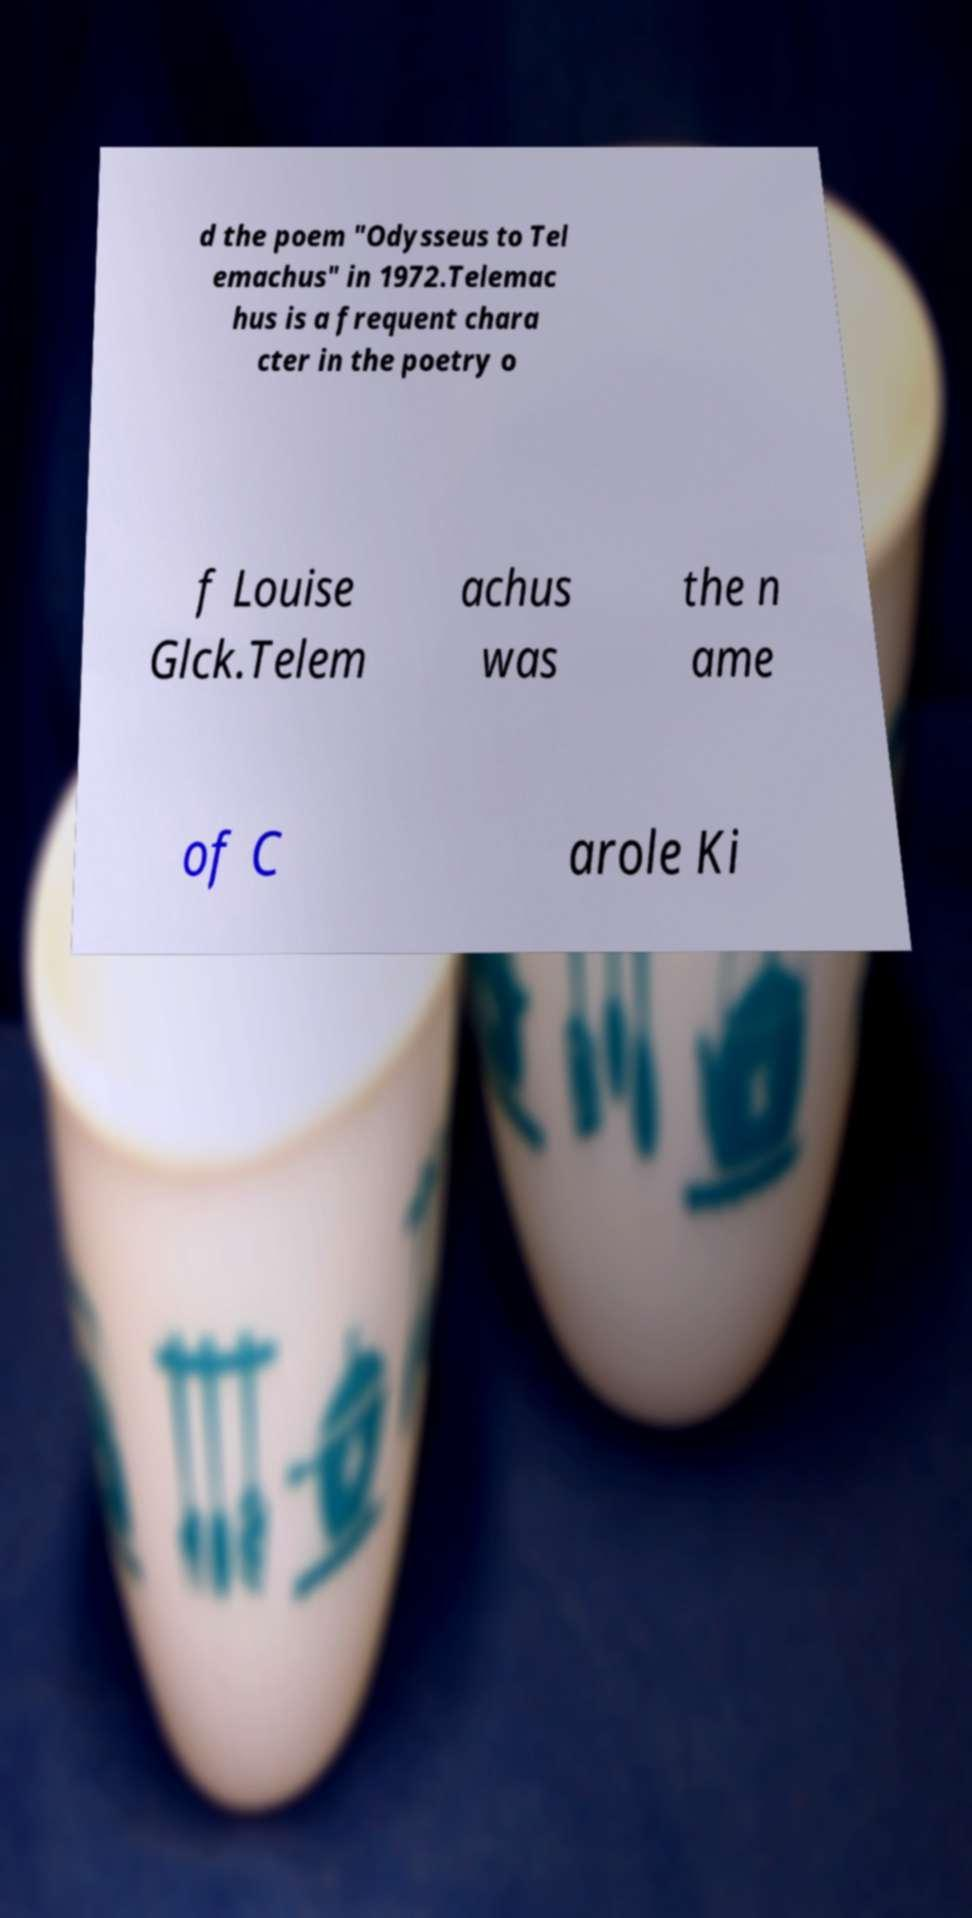Can you read and provide the text displayed in the image?This photo seems to have some interesting text. Can you extract and type it out for me? d the poem "Odysseus to Tel emachus" in 1972.Telemac hus is a frequent chara cter in the poetry o f Louise Glck.Telem achus was the n ame of C arole Ki 